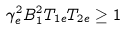<formula> <loc_0><loc_0><loc_500><loc_500>\gamma _ { e } ^ { 2 } B _ { 1 } ^ { 2 } T _ { 1 e } T _ { 2 e } \geq 1</formula> 